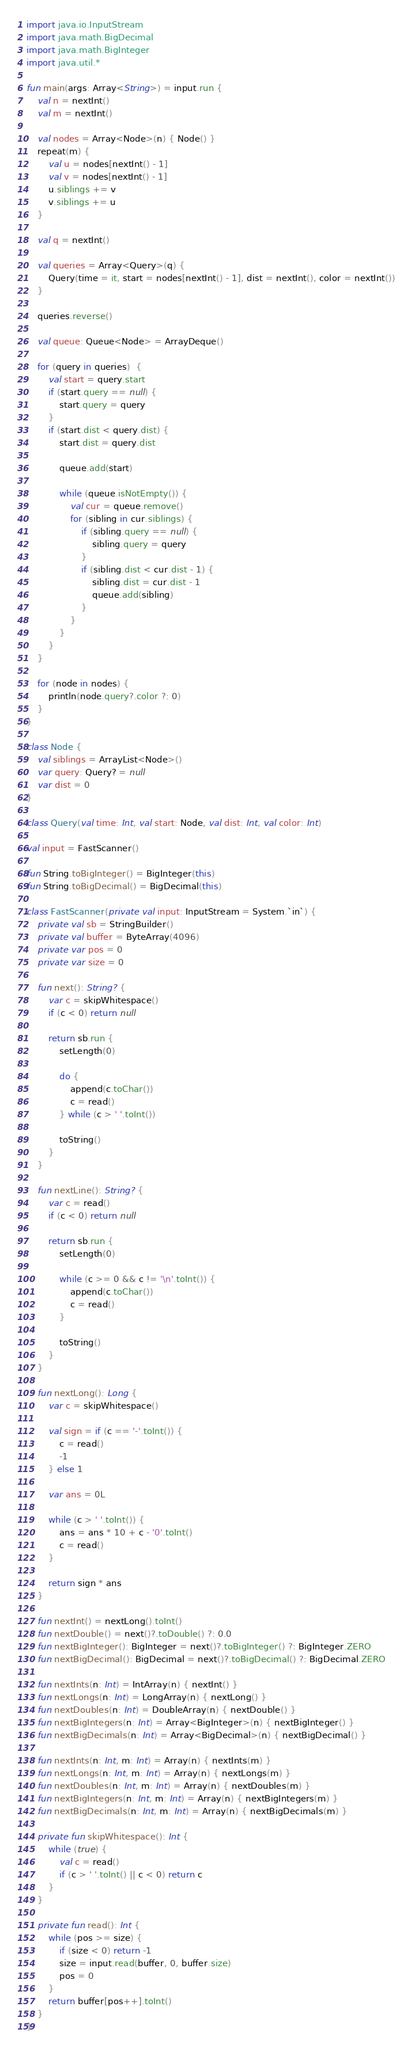Convert code to text. <code><loc_0><loc_0><loc_500><loc_500><_Kotlin_>import java.io.InputStream
import java.math.BigDecimal
import java.math.BigInteger
import java.util.*

fun main(args: Array<String>) = input.run {
    val n = nextInt()
    val m = nextInt()

    val nodes = Array<Node>(n) { Node() }
    repeat(m) {
        val u = nodes[nextInt() - 1]
        val v = nodes[nextInt() - 1]
        u.siblings += v
        v.siblings += u
    }

    val q = nextInt()

    val queries = Array<Query>(q) {
        Query(time = it, start = nodes[nextInt() - 1], dist = nextInt(), color = nextInt())
    }

    queries.reverse()

    val queue: Queue<Node> = ArrayDeque()

    for (query in queries)  {
        val start = query.start
        if (start.query == null) {
            start.query = query
        }
        if (start.dist < query.dist) {
            start.dist = query.dist

            queue.add(start)

            while (queue.isNotEmpty()) {
                val cur = queue.remove()
                for (sibling in cur.siblings) {
                    if (sibling.query == null) {
                        sibling.query = query
                    }
                    if (sibling.dist < cur.dist - 1) {
                        sibling.dist = cur.dist - 1
                        queue.add(sibling)
                    }
                }
            }
        }
    }

    for (node in nodes) {
        println(node.query?.color ?: 0)
    }
}

class Node {
    val siblings = ArrayList<Node>()
    var query: Query? = null
    var dist = 0
}

class Query(val time: Int, val start: Node, val dist: Int, val color: Int)

val input = FastScanner()

fun String.toBigInteger() = BigInteger(this)
fun String.toBigDecimal() = BigDecimal(this)

class FastScanner(private val input: InputStream = System.`in`) {
    private val sb = StringBuilder()
    private val buffer = ByteArray(4096)
    private var pos = 0
    private var size = 0

    fun next(): String? {
        var c = skipWhitespace()
        if (c < 0) return null

        return sb.run {
            setLength(0)

            do {
                append(c.toChar())
                c = read()
            } while (c > ' '.toInt())

            toString()
        }
    }

    fun nextLine(): String? {
        var c = read()
        if (c < 0) return null

        return sb.run {
            setLength(0)

            while (c >= 0 && c != '\n'.toInt()) {
                append(c.toChar())
                c = read()
            }

            toString()
        }
    }

    fun nextLong(): Long {
        var c = skipWhitespace()

        val sign = if (c == '-'.toInt()) {
            c = read()
            -1
        } else 1

        var ans = 0L

        while (c > ' '.toInt()) {
            ans = ans * 10 + c - '0'.toInt()
            c = read()
        }

        return sign * ans
    }

    fun nextInt() = nextLong().toInt()
    fun nextDouble() = next()?.toDouble() ?: 0.0
    fun nextBigInteger(): BigInteger = next()?.toBigInteger() ?: BigInteger.ZERO
    fun nextBigDecimal(): BigDecimal = next()?.toBigDecimal() ?: BigDecimal.ZERO

    fun nextInts(n: Int) = IntArray(n) { nextInt() }
    fun nextLongs(n: Int) = LongArray(n) { nextLong() }
    fun nextDoubles(n: Int) = DoubleArray(n) { nextDouble() }
    fun nextBigIntegers(n: Int) = Array<BigInteger>(n) { nextBigInteger() }
    fun nextBigDecimals(n: Int) = Array<BigDecimal>(n) { nextBigDecimal() }

    fun nextInts(n: Int, m: Int) = Array(n) { nextInts(m) }
    fun nextLongs(n: Int, m: Int) = Array(n) { nextLongs(m) }
    fun nextDoubles(n: Int, m: Int) = Array(n) { nextDoubles(m) }
    fun nextBigIntegers(n: Int, m: Int) = Array(n) { nextBigIntegers(m) }
    fun nextBigDecimals(n: Int, m: Int) = Array(n) { nextBigDecimals(m) }

    private fun skipWhitespace(): Int {
        while (true) {
            val c = read()
            if (c > ' '.toInt() || c < 0) return c
        }
    }

    private fun read(): Int {
        while (pos >= size) {
            if (size < 0) return -1
            size = input.read(buffer, 0, buffer.size)
            pos = 0
        }
        return buffer[pos++].toInt()
    }
}
</code> 